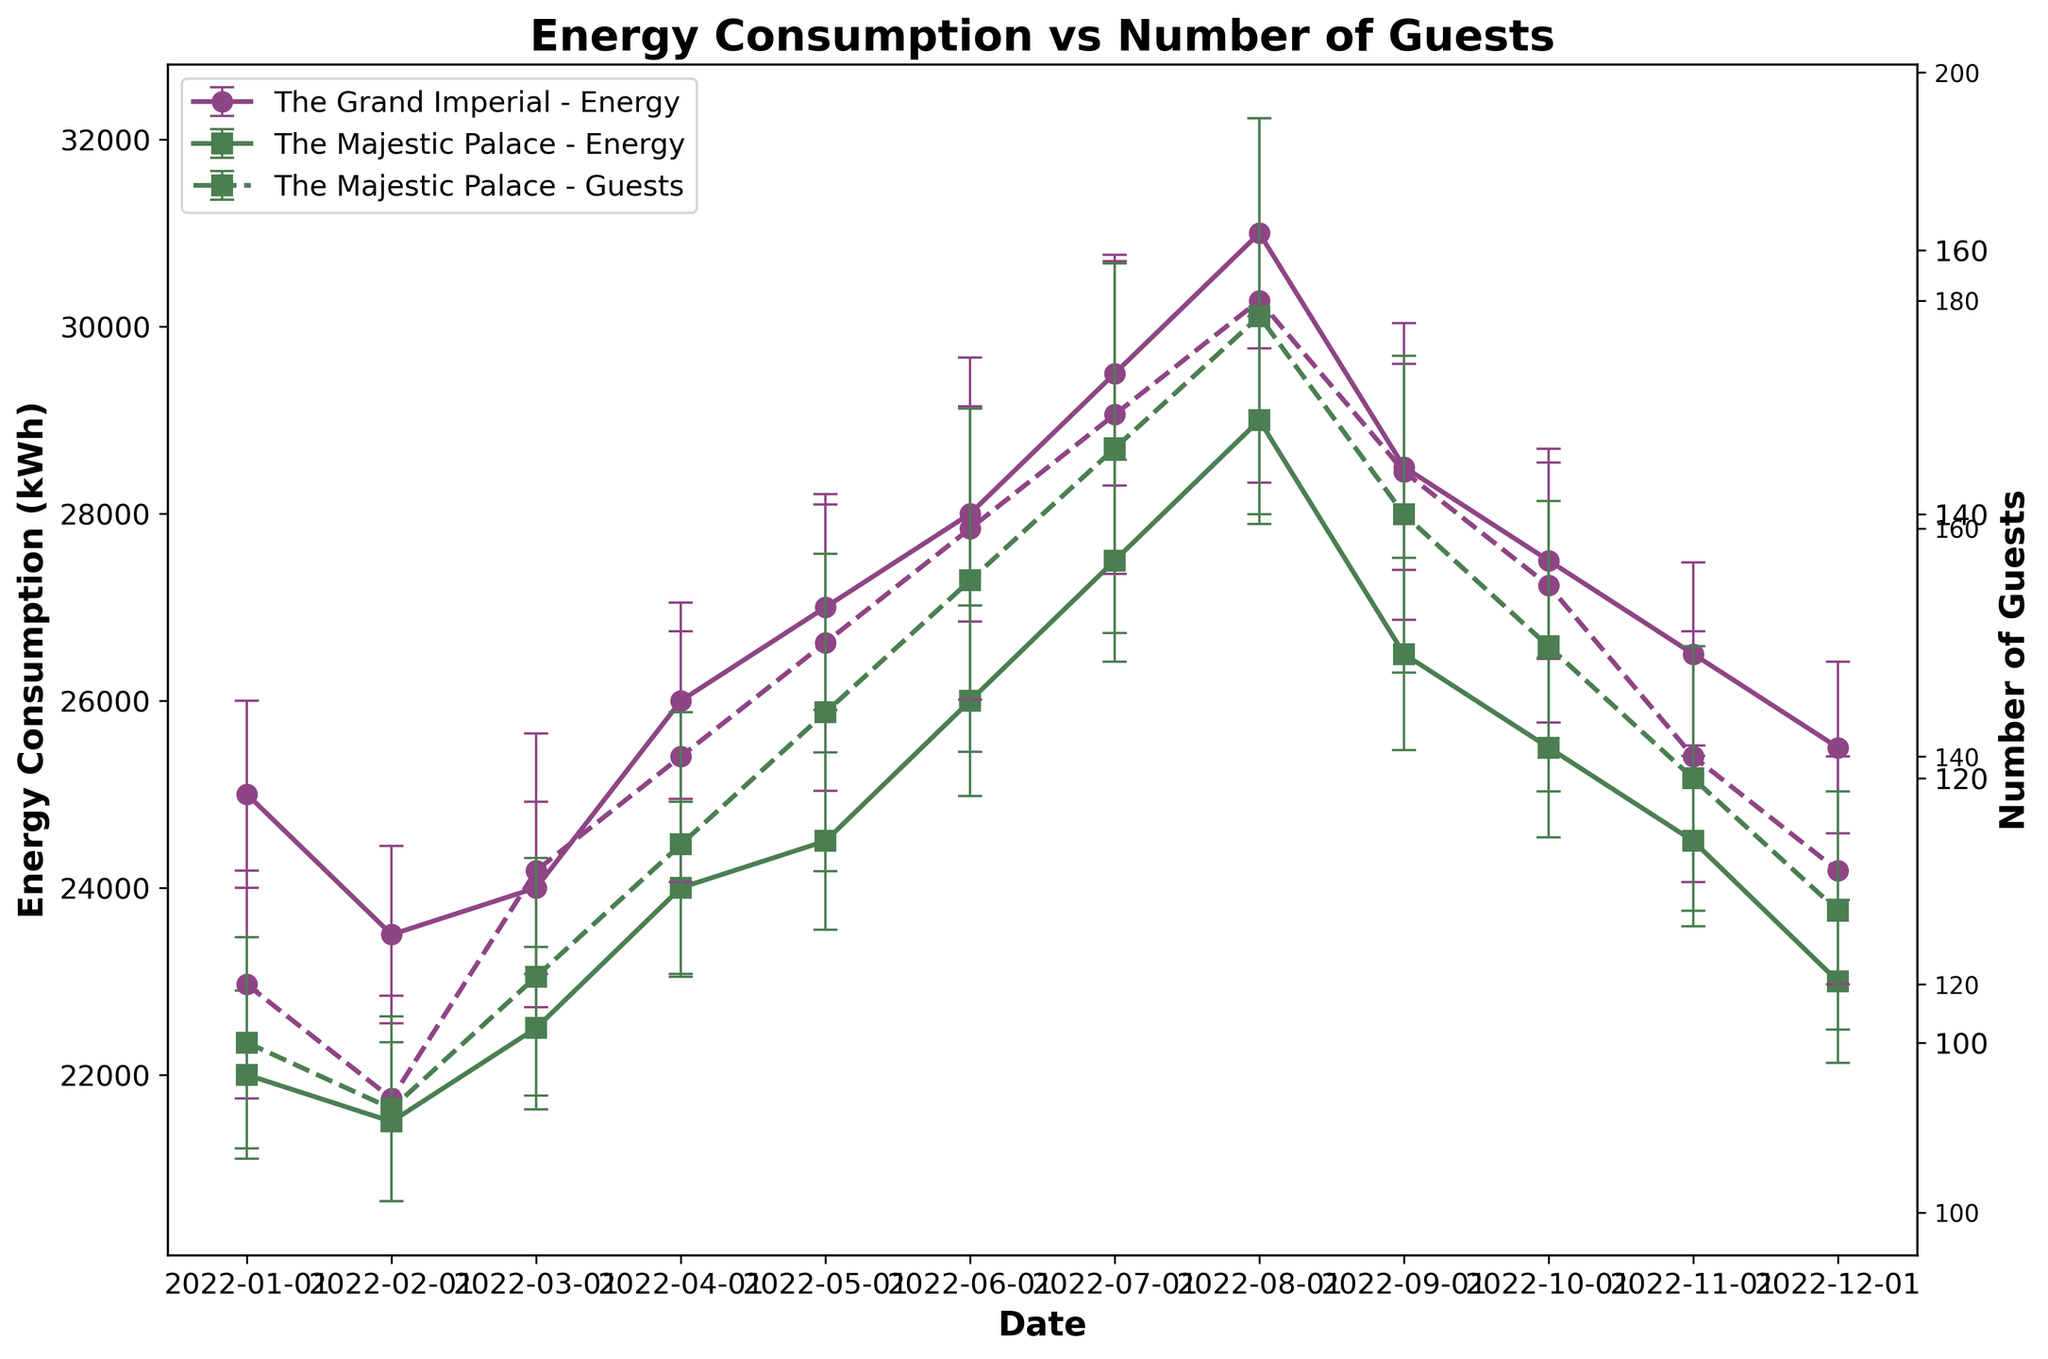What's the title of the plot? The title is usually located at the top of the plot and is meant to provide a brief description of what the plot represents. In this case, the title at the top reads "Energy Consumption vs Number of Guests".
Answer: Energy Consumption vs Number of Guests Which hotel had the highest energy consumption in August 2022? To determine which hotel had the highest energy consumption in August 2022, look at the vertical position of the error bars for each hotel in August 2022 and compare. The line representing "The Grand Imperial" is higher in August 2022 compared to "The Majestic Palace".
Answer: The Grand Imperial What is the energy consumption range for 'The Grand Imperial' in January 2022 considering the error bars? The range is calculated by adding and subtracting the standard deviation from the average energy consumption. For January 2022, the average consumption is 25000 kWh with an error of ±1000 kWh. Thus, the range is 25000 - 1000 to 25000 + 1000.
Answer: 24000 to 26000 kWh How did the number of guests in 'The Majestic Palace' change from January to December 2022? Trace the dashed line representing the number of guests at 'The Majestic Palace' from January to December. The number starts at 100 guests in January and ends at 110 guests in December, showing an increase.
Answer: Increase What is the average energy consumption for 'The Grand Imperial' from June to August 2022? To find the average, add the energy consumption values for June, July, and August, then divide by 3. The values are 28000 kWh, 29500 kWh, and 31000 kWh. Sum: 28000 + 29500 + 31000 = 88500, and the average = 88500 / 3 = 29500.
Answer: 29500 kWh Comparing October 2022, which hotel had higher energy consumption and by how much? Compare the energy consumption values for both hotels in October. "The Grand Imperial" had 27500 kWh and "The Majestic Palace" had 25500 kWh. The difference is 27500 - 25500 = 2000 kWh.
Answer: The Grand Imperial by 2000 kWh Which hotel showed a more significant increase in the number of guests from January to July 2022? Check the dashed lines' slopes from January to July for both hotels. The Grand Imperial increased from 120 to 170 (50 guests) and The Majestic Palace from 100 to 145 (45 guests).
Answer: The Grand Imperial What's the trend in energy consumption for 'The Majestic Palace' across 2022? Observe the solid line representing "The Majestic Palace." The energy consumption increases from January to August, then decreases from September to December.
Answer: Increase initially, then decrease What's the guest count range for 'The Majestic Palace' in May 2022 considering the error bars? The guest count for May is 125 with an error of ±12. Adding and subtracting the error gives the range: 125 - 12 to 125 + 12, which is 113 to 137.
Answer: 113 to 137 guests What relationship can we infer between the number of guests and energy consumption for 'The Grand Imperial' in 2022? As the number of guests predominantly increases, the energy consumption also increases, suggesting a positive correlation. This is seen by the upward trends in both solid (energy) and dashed (guests) lines.
Answer: Positive correlation 